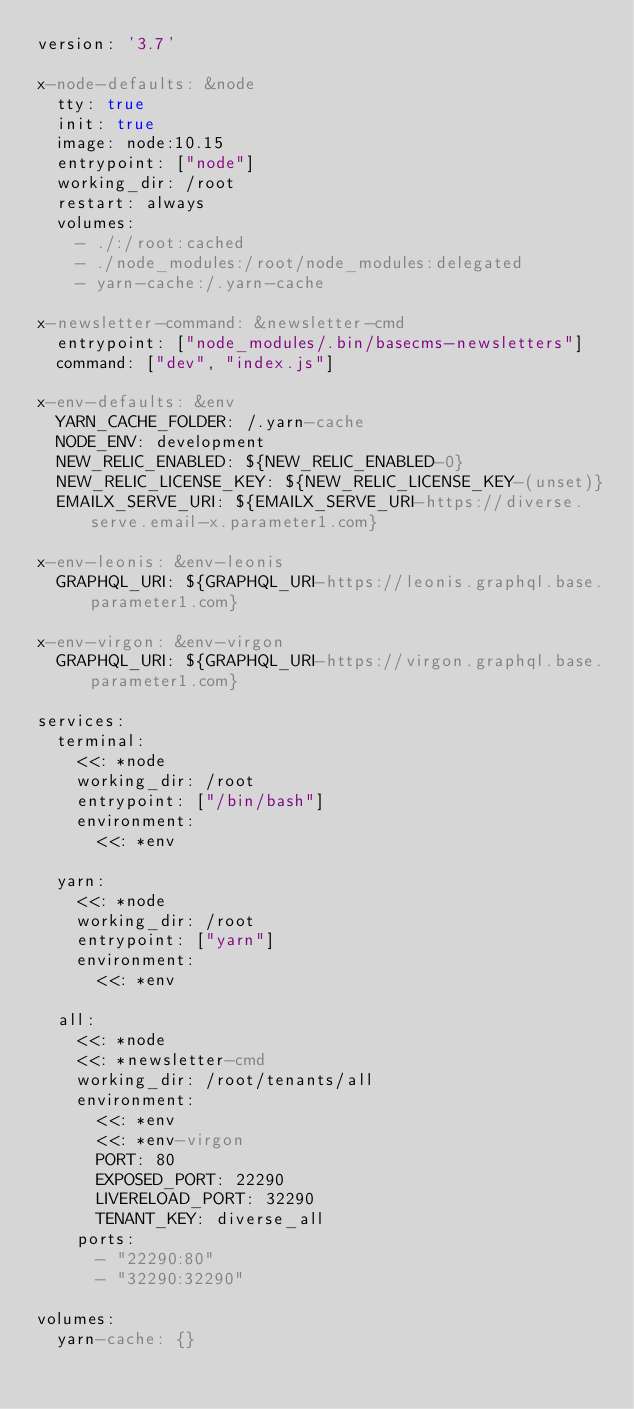Convert code to text. <code><loc_0><loc_0><loc_500><loc_500><_YAML_>version: '3.7'

x-node-defaults: &node
  tty: true
  init: true
  image: node:10.15
  entrypoint: ["node"]
  working_dir: /root
  restart: always
  volumes:
    - ./:/root:cached
    - ./node_modules:/root/node_modules:delegated
    - yarn-cache:/.yarn-cache

x-newsletter-command: &newsletter-cmd
  entrypoint: ["node_modules/.bin/basecms-newsletters"]
  command: ["dev", "index.js"]

x-env-defaults: &env
  YARN_CACHE_FOLDER: /.yarn-cache
  NODE_ENV: development
  NEW_RELIC_ENABLED: ${NEW_RELIC_ENABLED-0}
  NEW_RELIC_LICENSE_KEY: ${NEW_RELIC_LICENSE_KEY-(unset)}
  EMAILX_SERVE_URI: ${EMAILX_SERVE_URI-https://diverse.serve.email-x.parameter1.com}

x-env-leonis: &env-leonis
  GRAPHQL_URI: ${GRAPHQL_URI-https://leonis.graphql.base.parameter1.com}

x-env-virgon: &env-virgon
  GRAPHQL_URI: ${GRAPHQL_URI-https://virgon.graphql.base.parameter1.com}

services:
  terminal:
    <<: *node
    working_dir: /root
    entrypoint: ["/bin/bash"]
    environment:
      <<: *env

  yarn:
    <<: *node
    working_dir: /root
    entrypoint: ["yarn"]
    environment:
      <<: *env

  all:
    <<: *node
    <<: *newsletter-cmd
    working_dir: /root/tenants/all
    environment:
      <<: *env
      <<: *env-virgon
      PORT: 80
      EXPOSED_PORT: 22290
      LIVERELOAD_PORT: 32290
      TENANT_KEY: diverse_all
    ports:
      - "22290:80"
      - "32290:32290"

volumes:
  yarn-cache: {}
</code> 